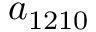<formula> <loc_0><loc_0><loc_500><loc_500>a _ { 1 2 1 0 }</formula> 